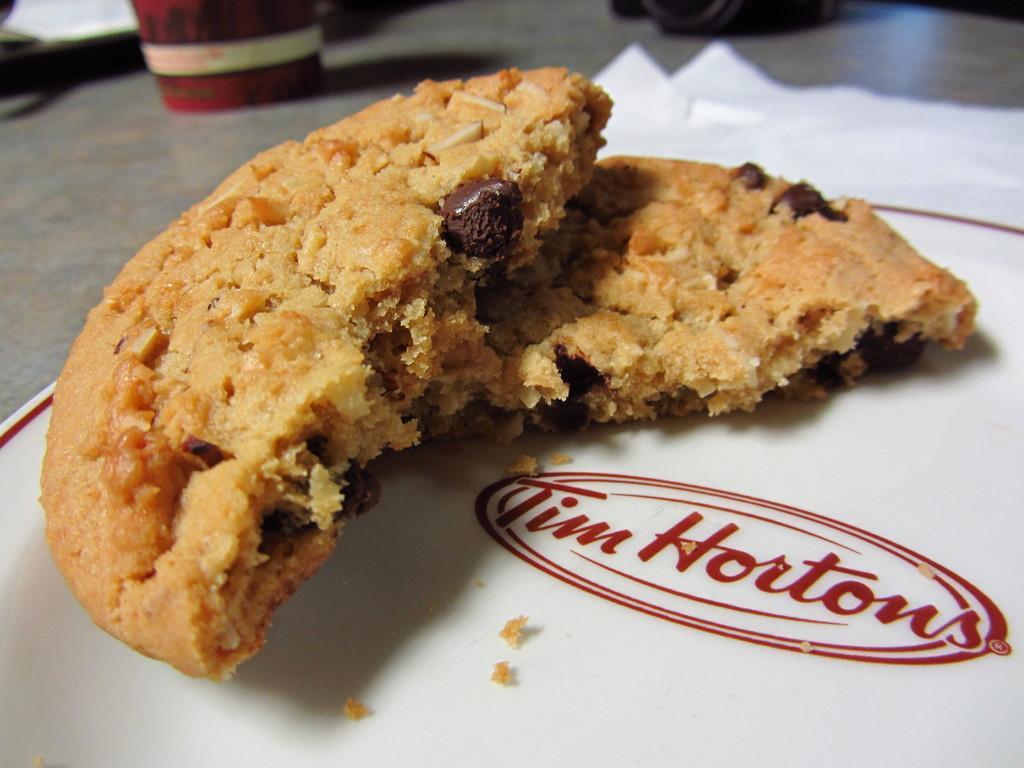Can you describe this image briefly? In the center of the image there are cookies on the paper. There is a glass. 